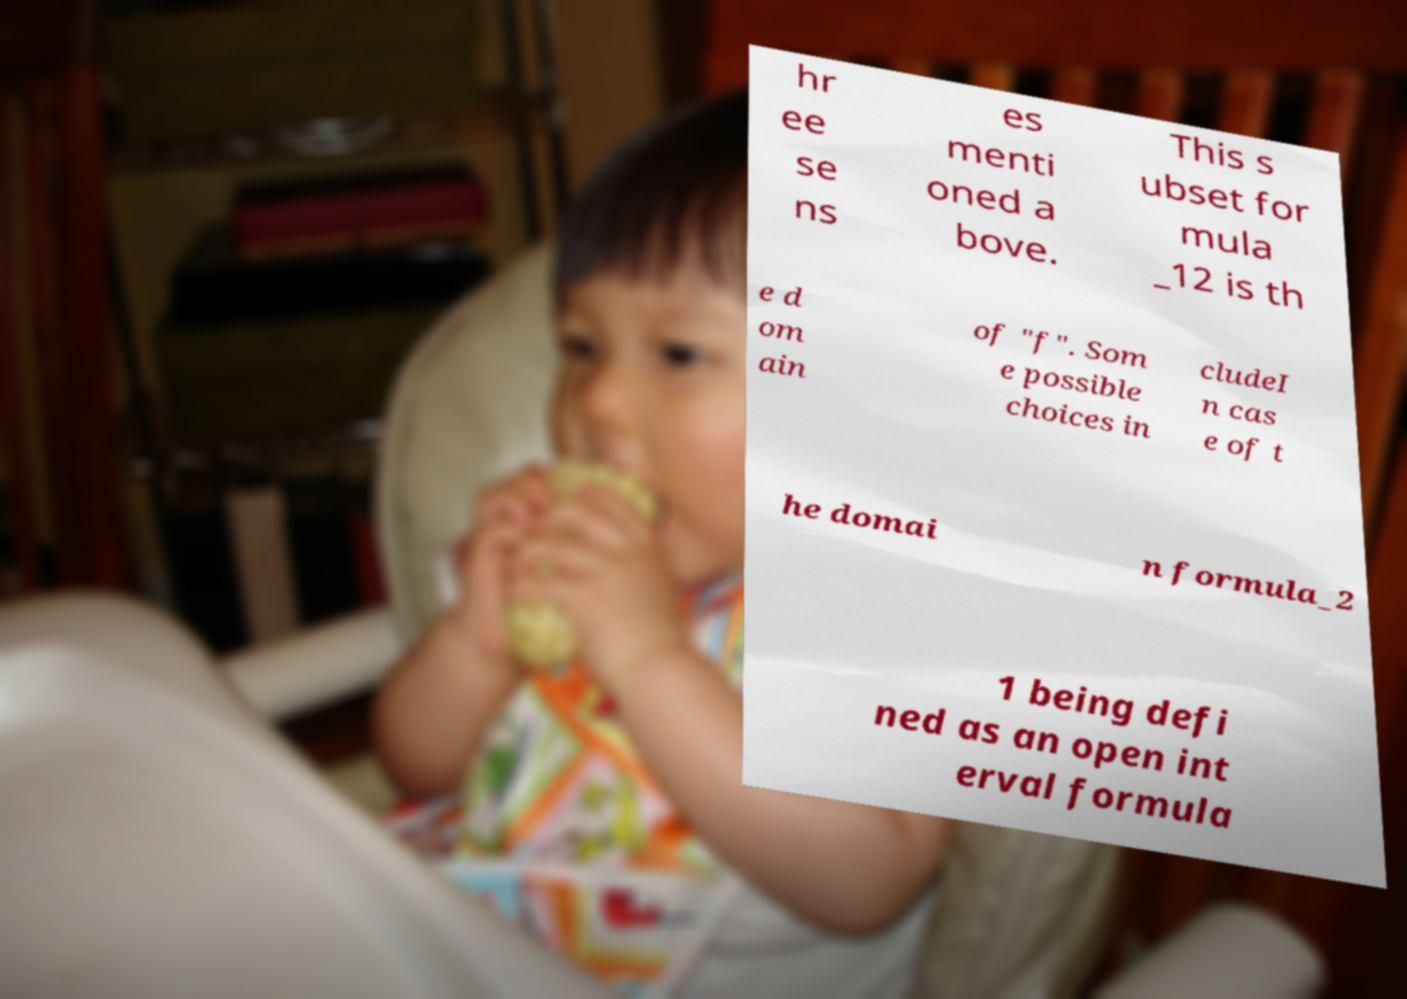There's text embedded in this image that I need extracted. Can you transcribe it verbatim? hr ee se ns es menti oned a bove. This s ubset for mula _12 is th e d om ain of "f". Som e possible choices in cludeI n cas e of t he domai n formula_2 1 being defi ned as an open int erval formula 